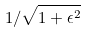Convert formula to latex. <formula><loc_0><loc_0><loc_500><loc_500>1 / \sqrt { 1 + \epsilon ^ { 2 } }</formula> 